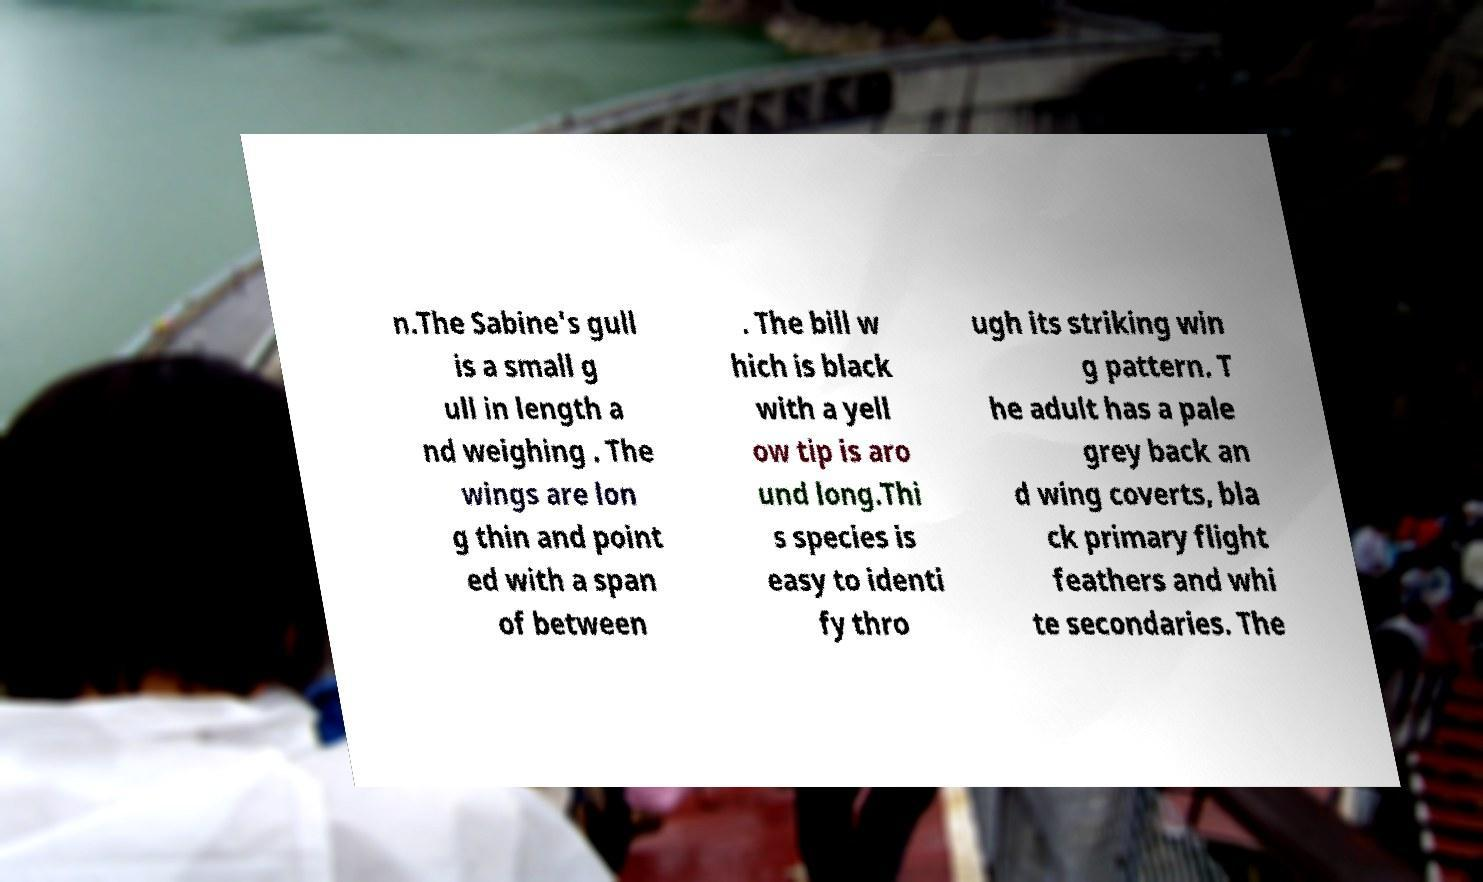Please identify and transcribe the text found in this image. n.The Sabine's gull is a small g ull in length a nd weighing . The wings are lon g thin and point ed with a span of between . The bill w hich is black with a yell ow tip is aro und long.Thi s species is easy to identi fy thro ugh its striking win g pattern. T he adult has a pale grey back an d wing coverts, bla ck primary flight feathers and whi te secondaries. The 